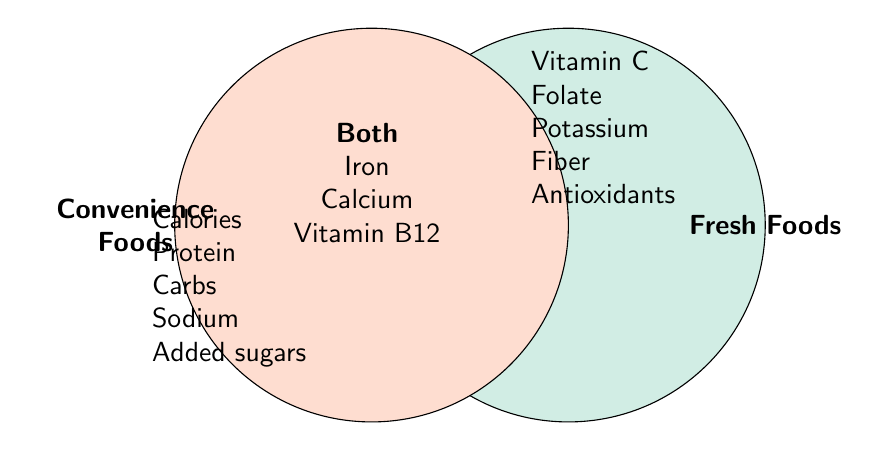What's listed under Fresh Foods? Fresh Foods are listed in the segment on the right side of the Venn diagram. The listed items are Vitamin C, Folate, Potassium, Fiber, and Antioxidants.
Answer: Vitamin C, Folate, Potassium, Fiber, Antioxidants Which nutrients are common in both Fresh Foods and Convenience Foods? Nutrients found in the overlapping area of the Venn diagram, indicating they exist in both categories, are Iron, Calcium, and Vitamin B12.
Answer: Iron, Calcium, Vitamin B12 Are there any vitamins exclusive to Fresh Foods? Which ones? The section labeled Fresh Foods contains specific vitamins not listed in any other section. These are Vitamin C and Folate.
Answer: Vitamin C, Folate How many nutrients are exclusive to Convenience Foods? Count the items in the section labeled Convenience Foods. There are five items listed: Calories, Protein, Carbohydrates, Sodium, and Added sugars.
Answer: 5 Do Antioxidants appear in Convenience Foods? Antioxidants are listed only in the Fresh Foods section of the Venn diagram, not in Convenience Foods.
Answer: No Which category has more unique nutrients, Fresh Foods or Convenience Foods? Compare the number of unique nutrients in the Fresh Foods section (5 items) and Convenience Foods section (5 items). Both categories have an equal number of unique nutrients.
Answer: Equal What are the three nutrients found in both Fresh and Convenience Foods? The overlapping section shows the three nutrients common to both Fresh and Convenience Foods: Iron, Calcium, and Vitamin B12.
Answer: Iron, Calcium, Vitamin B12 How do the nutrients in Fresh Foods differ from those in Convenience Foods? Fresh Foods contain Vitamin C, Folate, Potassium, Fiber, and Antioxidants, while Convenience Foods contain Calories, Protein, Carbohydrates, Sodium, and Added sugars.
Answer: Different sets of nutrients Is Fiber present in Convenience Foods according to the figure? Fiber is mentioned only in the Fresh Foods section of the Venn diagram, indicating it's not present in Convenience Foods.
Answer: No 